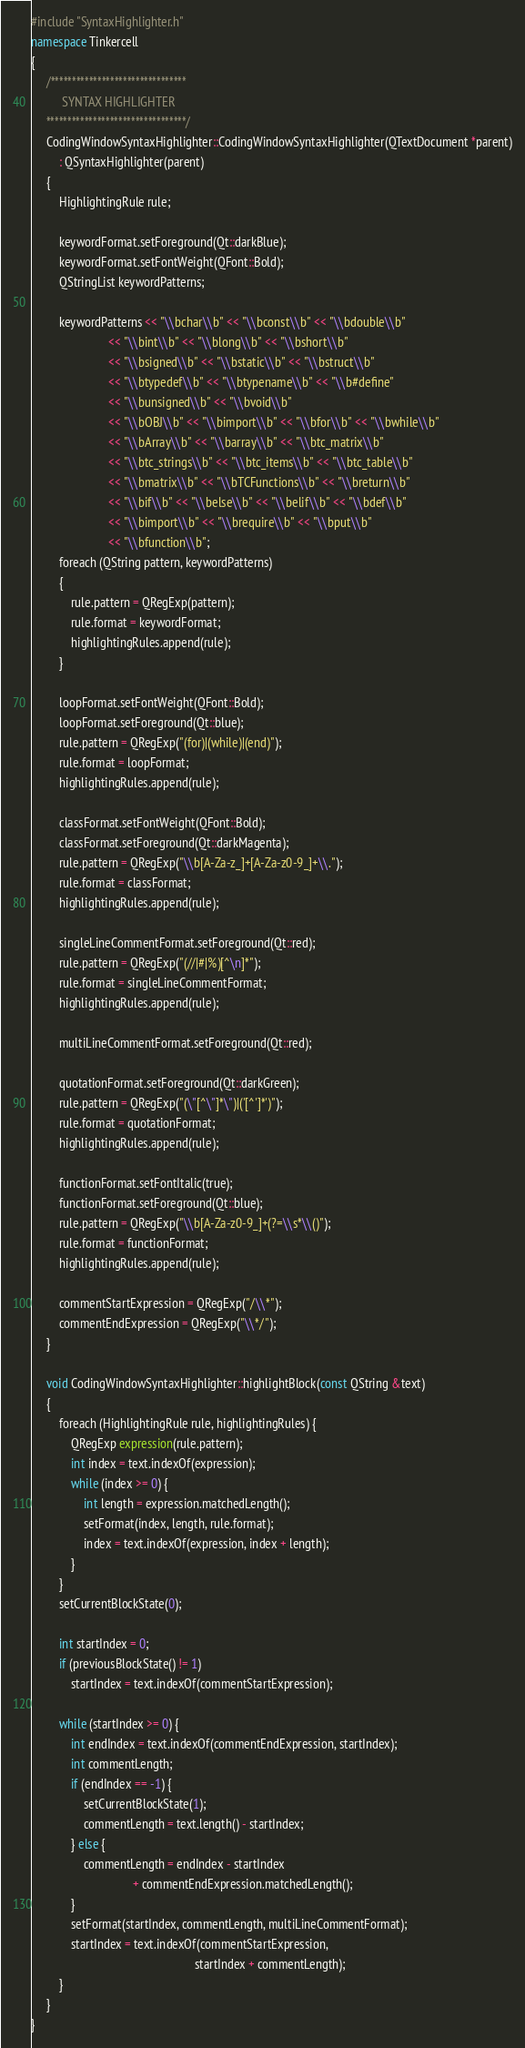Convert code to text. <code><loc_0><loc_0><loc_500><loc_500><_C++_>#include "SyntaxHighlighter.h"
namespace Tinkercell
{
	 /********************************
	      SYNTAX HIGHLIGHTER
	 *********************************/
	 CodingWindowSyntaxHighlighter::CodingWindowSyntaxHighlighter(QTextDocument *parent)
		 : QSyntaxHighlighter(parent)
	 {
		 HighlightingRule rule;

		 keywordFormat.setForeground(Qt::darkBlue);
		 keywordFormat.setFontWeight(QFont::Bold);
		 QStringList keywordPatterns;
		 
		 keywordPatterns << "\\bchar\\b" << "\\bconst\\b" << "\\bdouble\\b" 
						 << "\\bint\\b" << "\\blong\\b" << "\\bshort\\b" 
						 << "\\bsigned\\b" << "\\bstatic\\b" << "\\bstruct\\b"
						 << "\\btypedef\\b" << "\\btypename\\b" << "\\b#define"
						 << "\\bunsigned\\b" << "\\bvoid\\b" 
						 << "\\bOBJ\\b" << "\\bimport\\b" << "\\bfor\\b" << "\\bwhile\\b"
						 << "\\bArray\\b" << "\\barray\\b" << "\\btc_matrix\\b"
						 << "\\btc_strings\\b" << "\\btc_items\\b" << "\\btc_table\\b"
						 << "\\bmatrix\\b" << "\\bTCFunctions\\b" << "\\breturn\\b"
						 << "\\bif\\b" << "\\belse\\b" << "\\belif\\b" << "\\bdef\\b"
 						 << "\\bimport\\b" << "\\brequire\\b" << "\\bput\\b"
						 << "\\bfunction\\b";
		 foreach (QString pattern, keywordPatterns) 
		 {
			 rule.pattern = QRegExp(pattern);
			 rule.format = keywordFormat;
			 highlightingRules.append(rule);
		 }
		 
		 loopFormat.setFontWeight(QFont::Bold);
		 loopFormat.setForeground(Qt::blue);
		 rule.pattern = QRegExp("(for)|(while)|(end)");
		 rule.format = loopFormat;
		 highlightingRules.append(rule);
		 
		 classFormat.setFontWeight(QFont::Bold);
		 classFormat.setForeground(Qt::darkMagenta);
		 rule.pattern = QRegExp("\\b[A-Za-z_]+[A-Za-z0-9_]+\\.");
		 rule.format = classFormat;
		 highlightingRules.append(rule);

		 singleLineCommentFormat.setForeground(Qt::red);
		 rule.pattern = QRegExp("(//|#|%)[^\n]*");
		 rule.format = singleLineCommentFormat;
		 highlightingRules.append(rule);

		 multiLineCommentFormat.setForeground(Qt::red);

		 quotationFormat.setForeground(Qt::darkGreen);
		 rule.pattern = QRegExp("(\"[^\"]*\")|('[^']*')");
		 rule.format = quotationFormat;
		 highlightingRules.append(rule);

		 functionFormat.setFontItalic(true);
		 functionFormat.setForeground(Qt::blue);
		 rule.pattern = QRegExp("\\b[A-Za-z0-9_]+(?=\\s*\\()");
		 rule.format = functionFormat;
		 highlightingRules.append(rule);

		 commentStartExpression = QRegExp("/\\*");
		 commentEndExpression = QRegExp("\\*/");
	 }

	 void CodingWindowSyntaxHighlighter::highlightBlock(const QString &text)
	 {
		 foreach (HighlightingRule rule, highlightingRules) {
			 QRegExp expression(rule.pattern);
			 int index = text.indexOf(expression);
			 while (index >= 0) {
				 int length = expression.matchedLength();
				 setFormat(index, length, rule.format);
				 index = text.indexOf(expression, index + length);
			 }
		 }
		 setCurrentBlockState(0);

		 int startIndex = 0;
		 if (previousBlockState() != 1)
			 startIndex = text.indexOf(commentStartExpression);

		 while (startIndex >= 0) {
			 int endIndex = text.indexOf(commentEndExpression, startIndex);
			 int commentLength;
			 if (endIndex == -1) {
				 setCurrentBlockState(1);
				 commentLength = text.length() - startIndex;
			 } else {
				 commentLength = endIndex - startIndex
								 + commentEndExpression.matchedLength();
			 }
			 setFormat(startIndex, commentLength, multiLineCommentFormat);
			 startIndex = text.indexOf(commentStartExpression,
													 startIndex + commentLength);
		 }
	 }
}
</code> 